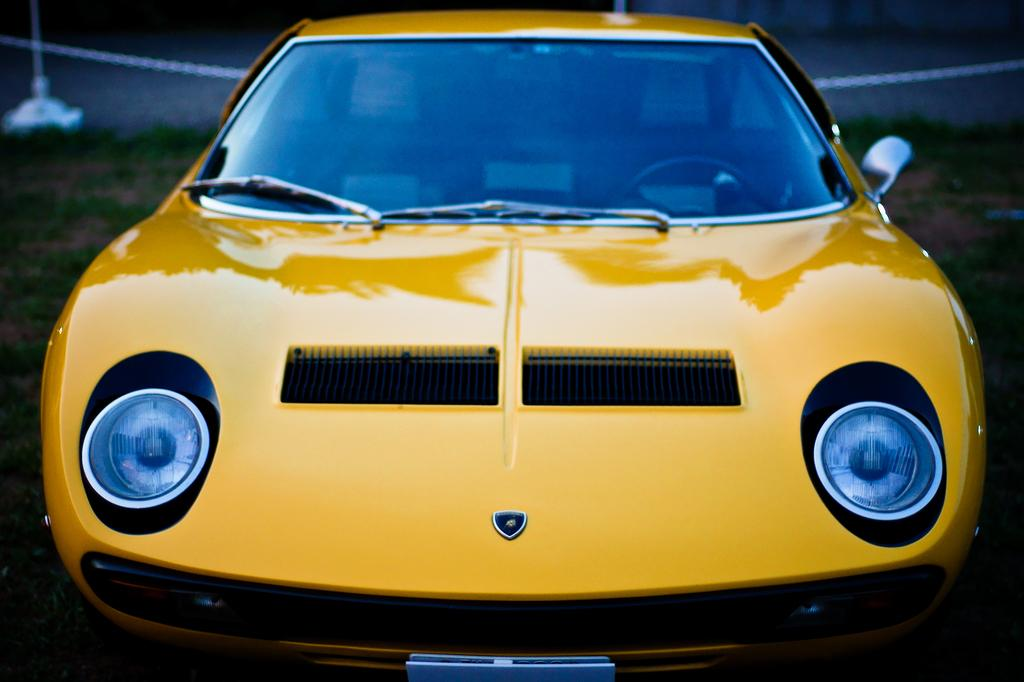What color is the car in the image? The car in the image is yellow. Can you describe the type of vehicle in the image? The image features a car. Is there a cave in the background of the image? There is no mention of a cave in the image, and it cannot be determined from the provided facts. 